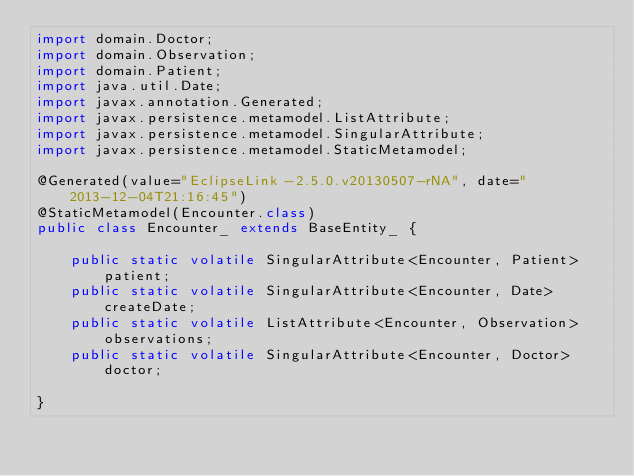Convert code to text. <code><loc_0><loc_0><loc_500><loc_500><_Java_>import domain.Doctor;
import domain.Observation;
import domain.Patient;
import java.util.Date;
import javax.annotation.Generated;
import javax.persistence.metamodel.ListAttribute;
import javax.persistence.metamodel.SingularAttribute;
import javax.persistence.metamodel.StaticMetamodel;

@Generated(value="EclipseLink-2.5.0.v20130507-rNA", date="2013-12-04T21:16:45")
@StaticMetamodel(Encounter.class)
public class Encounter_ extends BaseEntity_ {

    public static volatile SingularAttribute<Encounter, Patient> patient;
    public static volatile SingularAttribute<Encounter, Date> createDate;
    public static volatile ListAttribute<Encounter, Observation> observations;
    public static volatile SingularAttribute<Encounter, Doctor> doctor;

}</code> 